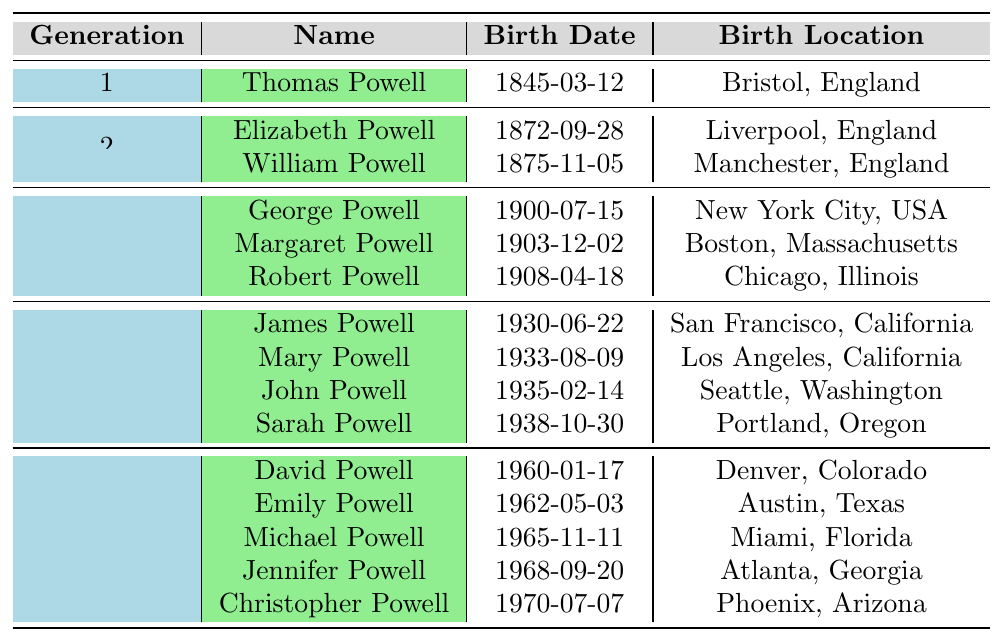What is the birth date of Thomas Powell? The table lists Thomas Powell's birth date as 1845-03-12 under Generation 1.
Answer: 1845-03-12 Which generation does Mary Powell belong to? Mary Powell is listed in the fourth row with her generation indicated as Generation 4.
Answer: Generation 4 How many members are there in Generation 3? The table indicates that there are three members listed in Generation 3: George, Margaret, and Robert Powell.
Answer: 3 What is the birth location of Elizabeth Powell? The table states that Elizabeth Powell was born in Liverpool, England, listed under Generation 2.
Answer: Liverpool, England Which Powell family member was born in Chicago, Illinois? The table identifies Robert Powell as the family member born in Chicago, Illinois, and he is in Generation 3.
Answer: Robert Powell How many years apart were Thomas Powell and Elizabeth Powell born? Thomas Powell was born in 1845 and Elizabeth Powell in 1872; thus, the difference is 1872 - 1845 = 27 years.
Answer: 27 years Does any member of Generation 5 have a birth location in Texas? The table indicates that Emily Powell, a Generation 5 member, was born in Austin, Texas.
Answer: Yes What is the average birth year for members of Generation 4? The birth years for Generation 4 are 1930, 1933, 1935, and 1938. Calculating the average: (1930 + 1933 + 1935 + 1938) / 4 = 1934.
Answer: 1934 Which Powell family member has the most recent birth date? The table shows that Christopher Powell has the most recent birth date of 1970-07-07 among the members listed.
Answer: Christopher Powell Is there a member of the Powell family who was born in Boston, Massachusetts? Yes, the table shows that Margaret Powell was born in Boston, Massachusetts, listed in Generation 3.
Answer: Yes 